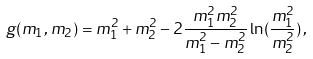<formula> <loc_0><loc_0><loc_500><loc_500>g ( m _ { 1 } , m _ { 2 } ) = m _ { 1 } ^ { 2 } + m _ { 2 } ^ { 2 } - 2 \frac { m _ { 1 } ^ { 2 } m _ { 2 } ^ { 2 } } { m _ { 1 } ^ { 2 } - m _ { 2 } ^ { 2 } } \ln ( \frac { m _ { 1 } ^ { 2 } } { m _ { 2 } ^ { 2 } } ) \, ,</formula> 